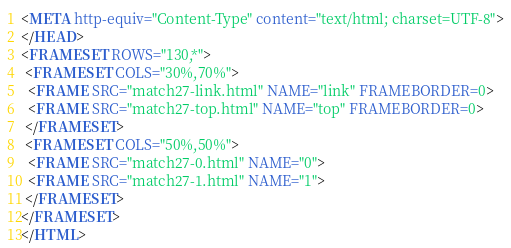<code> <loc_0><loc_0><loc_500><loc_500><_HTML_><META http-equiv="Content-Type" content="text/html; charset=UTF-8">
</HEAD>
<FRAMESET ROWS="130,*">
 <FRAMESET COLS="30%,70%">
  <FRAME SRC="match27-link.html" NAME="link" FRAMEBORDER=0>
  <FRAME SRC="match27-top.html" NAME="top" FRAMEBORDER=0>
 </FRAMESET>
 <FRAMESET COLS="50%,50%">
  <FRAME SRC="match27-0.html" NAME="0">
  <FRAME SRC="match27-1.html" NAME="1">
 </FRAMESET>
</FRAMESET>
</HTML>
</code> 